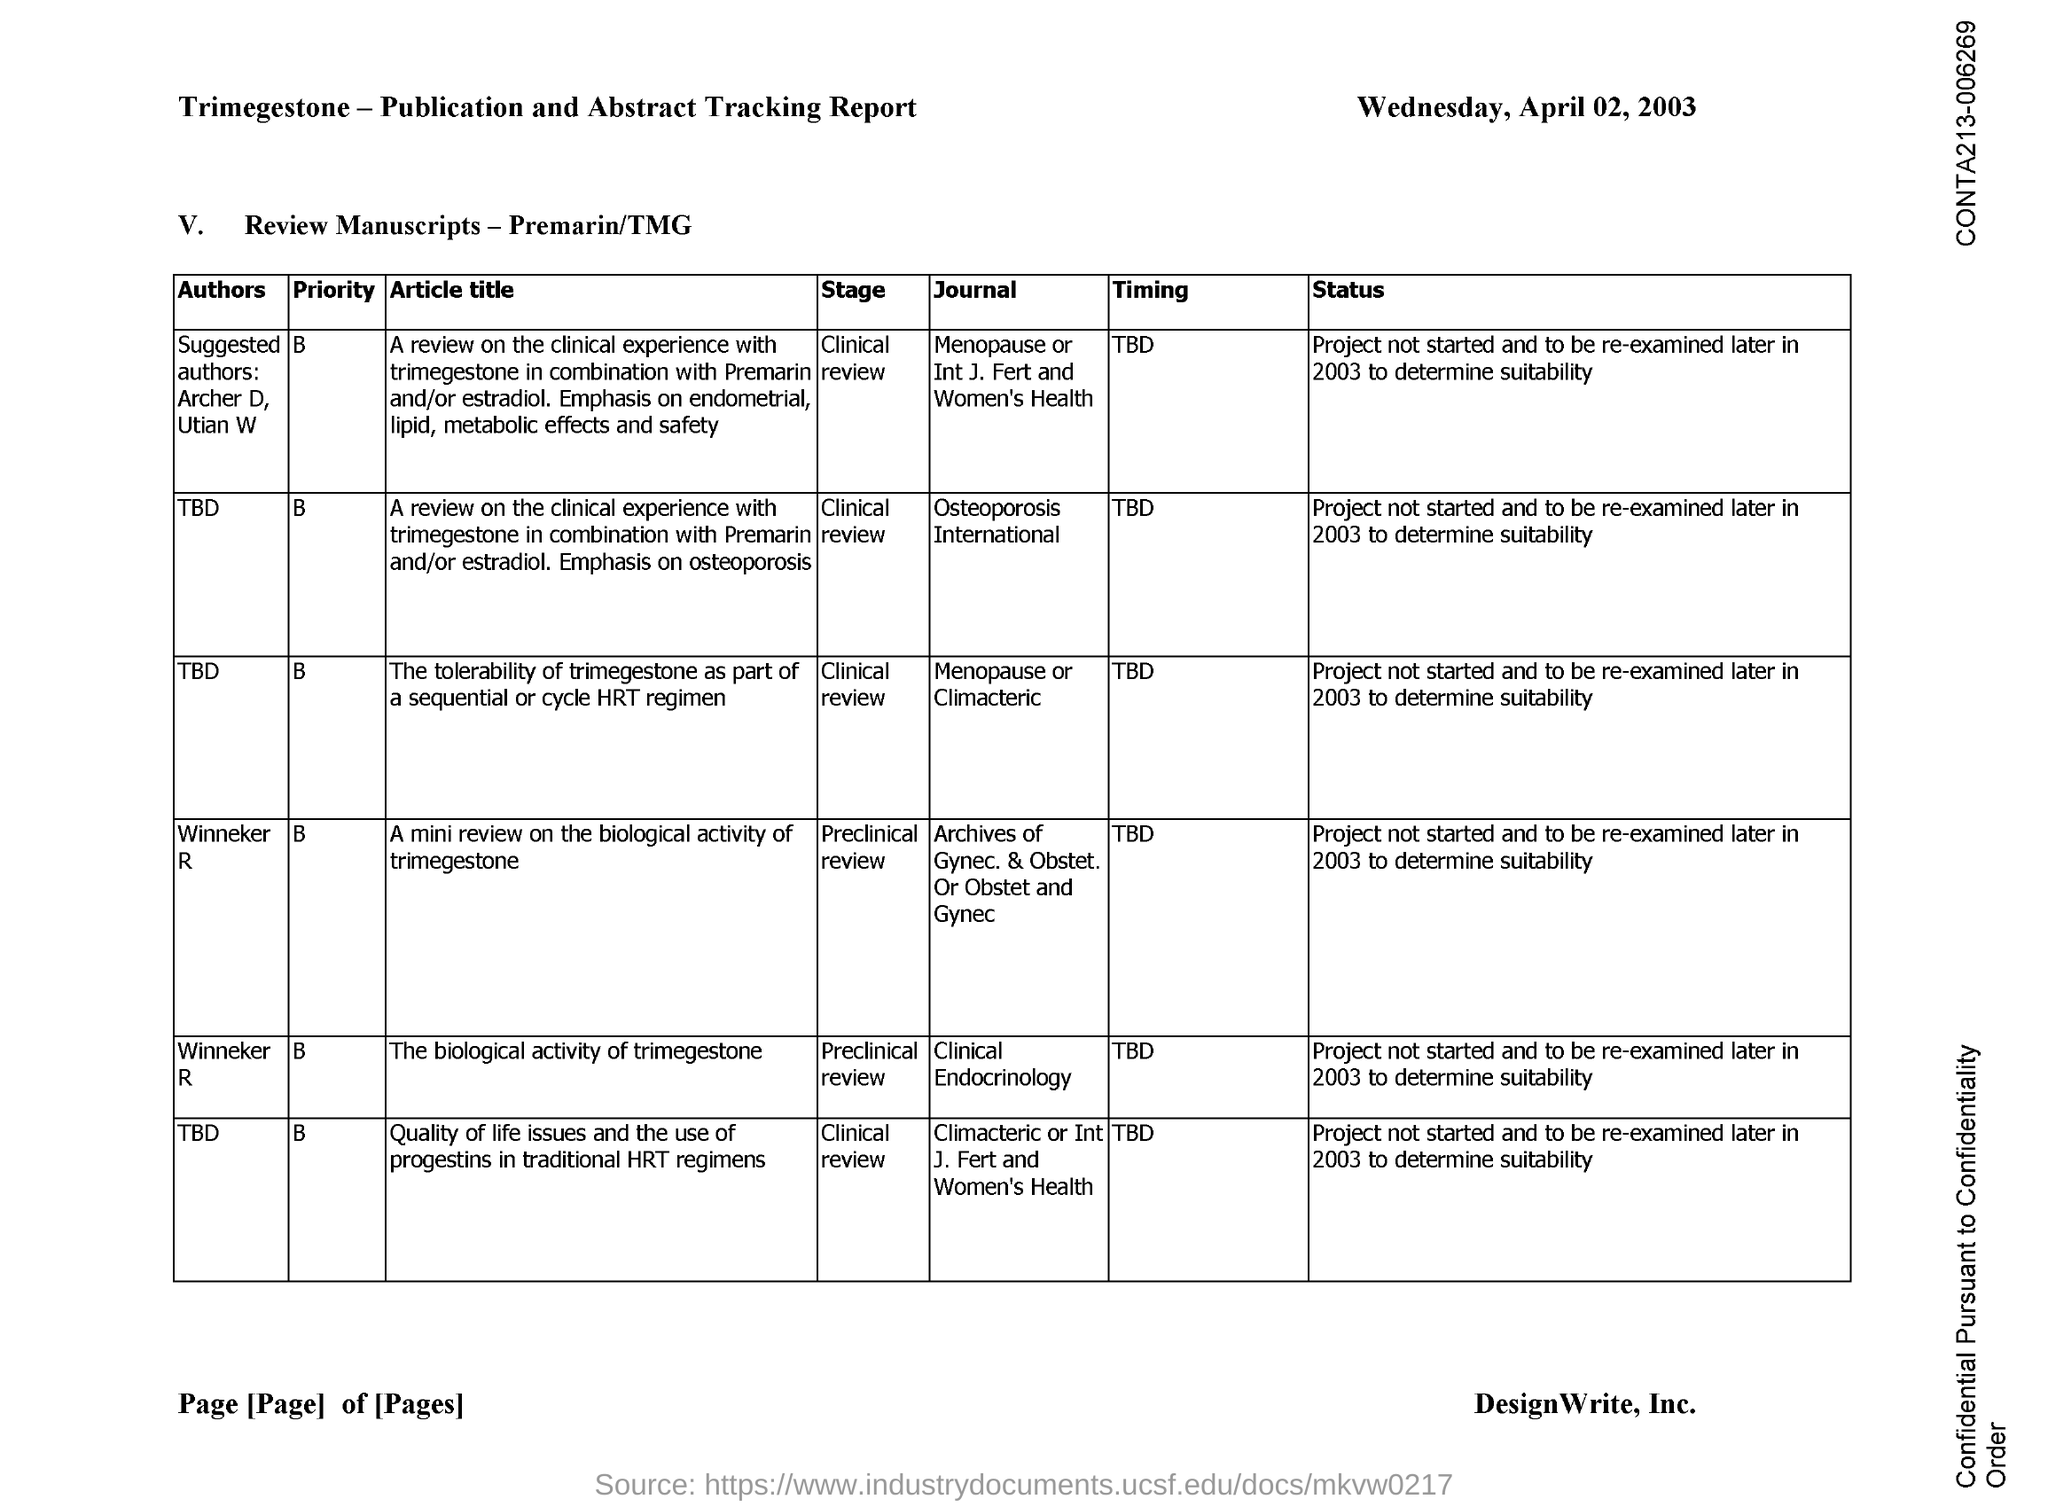List a handful of essential elements in this visual. The document is dated Wednesday, April 02, 2003. Winneker R. is the author of the article "The biological activity of trimegestone. 